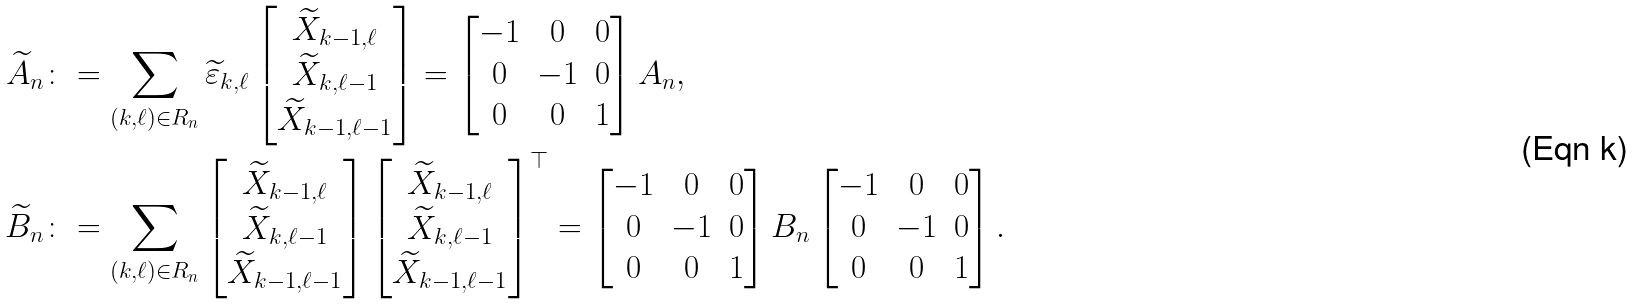Convert formula to latex. <formula><loc_0><loc_0><loc_500><loc_500>\widetilde { A } _ { n } & \colon = \sum _ { ( k , \ell ) \in R _ { n } } \widetilde { \varepsilon } _ { k , \ell } \begin{bmatrix} \widetilde { X } _ { k - 1 , \ell } \\ \widetilde { X } _ { k , \ell - 1 } \\ \widetilde { X } _ { k - 1 , \ell - 1 } \end{bmatrix} = \begin{bmatrix} - 1 & 0 & 0 \\ 0 & - 1 & 0 \\ 0 & 0 & 1 \end{bmatrix} A _ { n } , \\ \widetilde { B } _ { n } & \colon = \sum _ { ( k , \ell ) \in R _ { n } } \begin{bmatrix} \widetilde { X } _ { k - 1 , \ell } \\ \widetilde { X } _ { k , \ell - 1 } \\ \widetilde { X } _ { k - 1 , \ell - 1 } \end{bmatrix} \begin{bmatrix} \widetilde { X } _ { k - 1 , \ell } \\ \widetilde { X } _ { k , \ell - 1 } \\ \widetilde { X } _ { k - 1 , \ell - 1 } \end{bmatrix} ^ { \top } = \begin{bmatrix} - 1 & 0 & 0 \\ 0 & - 1 & 0 \\ 0 & 0 & 1 \end{bmatrix} B _ { n } \begin{bmatrix} - 1 & 0 & 0 \\ 0 & - 1 & 0 \\ 0 & 0 & 1 \end{bmatrix} .</formula> 